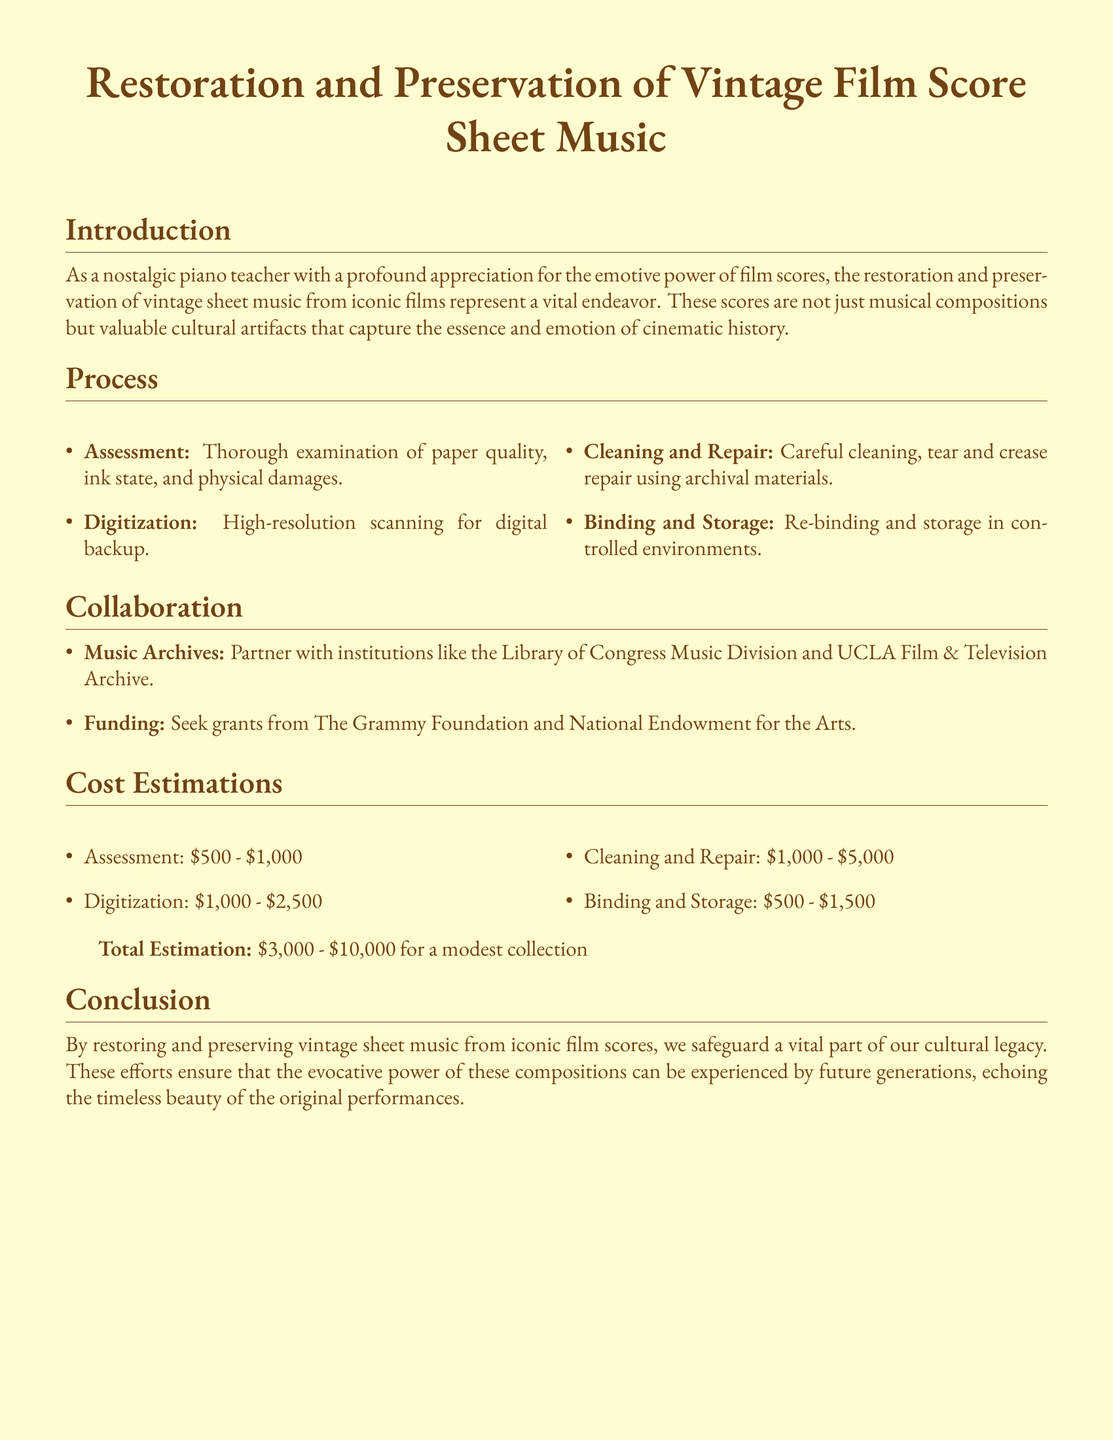What is the title of the proposal? The title of the proposal is the first line of the document, highlighting the main focus of the content.
Answer: Restoration and Preservation of Vintage Film Score Sheet Music What types of institutions will collaborate on this project? The collaboration section mentions specific types of institutions that will partner in this proposal.
Answer: Music Archives What is the cost range for cleaning and repair? This cost estimation is provided in a list format within the document detailing specific expenses.
Answer: One thousand to five thousand dollars Which division of the Library of Congress is mentioned for collaboration? This information is specified in the collaboration section as part of the institutional partnerships.
Answer: Music Division What is the total cost estimation for a modest collection? The total estimation is stated directly after providing the cost estimates for various processes in the document.
Answer: Three thousand to ten thousand dollars What are the first steps in the restoration process? The process section lists the initial steps, which start after the introduction.
Answer: Assessment How will the vintage sheet music be preserved after cleaning and repair? The process section describes the final steps that include protecting the restored material.
Answer: Binding and Storage What is the purpose of this proposal? The introduction outlines the overarching aim and significance of the work presented in the document.
Answer: Safeguard a vital part of our cultural legacy What are potential funding sources mentioned? The collaboration section identifies organizations that could provide financial support for the project.
Answer: The Grammy Foundation and National Endowment for the Arts 